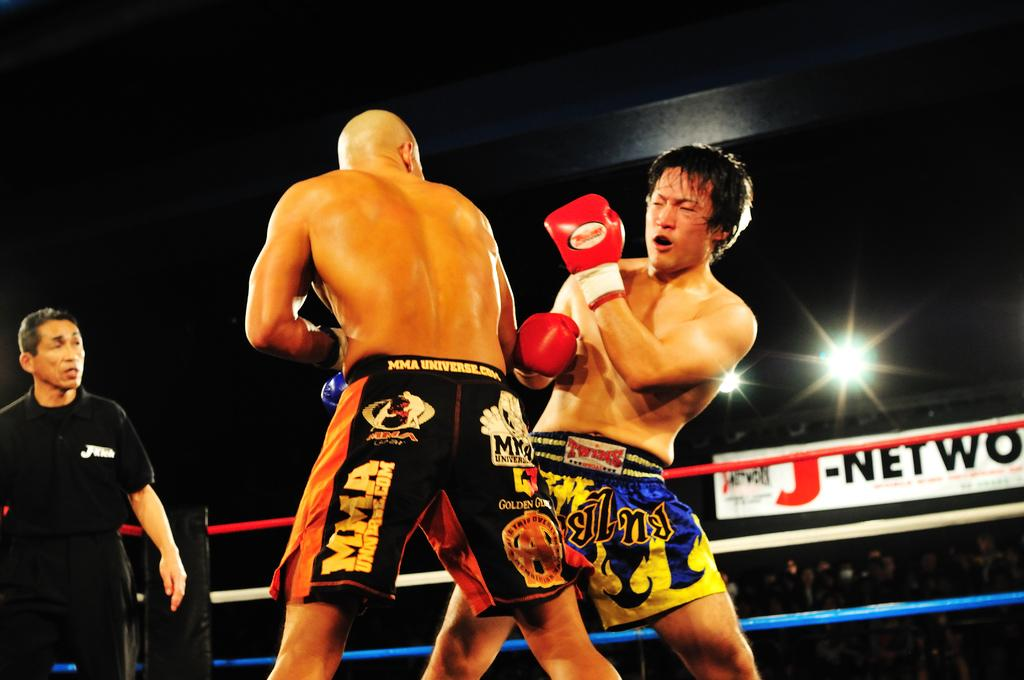Provide a one-sentence caption for the provided image. Two MMA Universe fighters close to each other while the referee observes. 